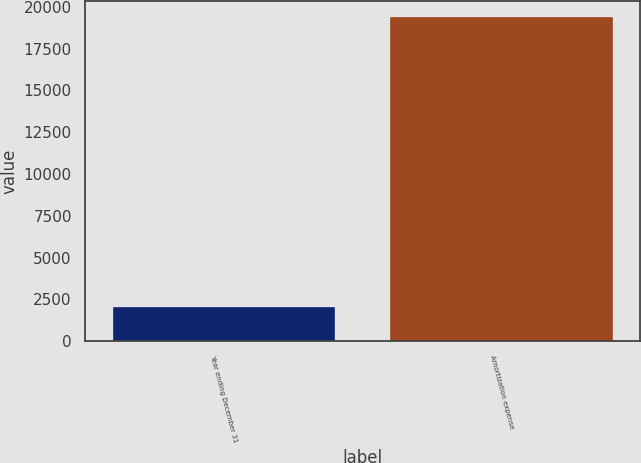Convert chart. <chart><loc_0><loc_0><loc_500><loc_500><bar_chart><fcel>Year ending December 31<fcel>Amortization expense<nl><fcel>2020<fcel>19360<nl></chart> 